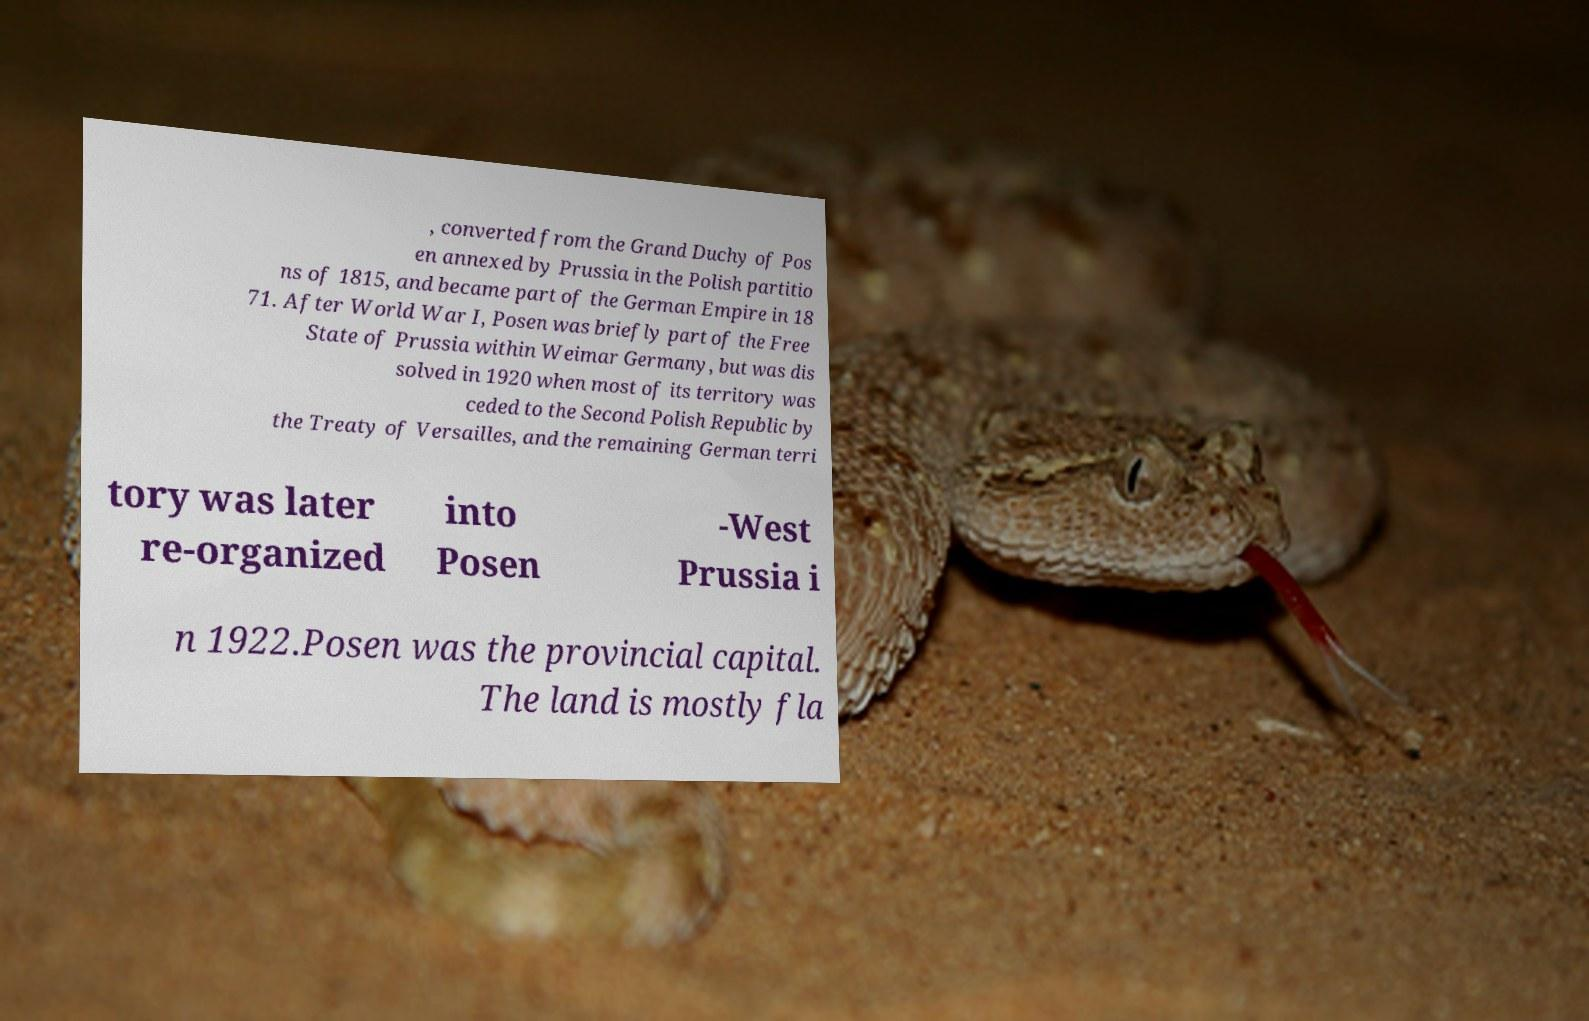There's text embedded in this image that I need extracted. Can you transcribe it verbatim? , converted from the Grand Duchy of Pos en annexed by Prussia in the Polish partitio ns of 1815, and became part of the German Empire in 18 71. After World War I, Posen was briefly part of the Free State of Prussia within Weimar Germany, but was dis solved in 1920 when most of its territory was ceded to the Second Polish Republic by the Treaty of Versailles, and the remaining German terri tory was later re-organized into Posen -West Prussia i n 1922.Posen was the provincial capital. The land is mostly fla 